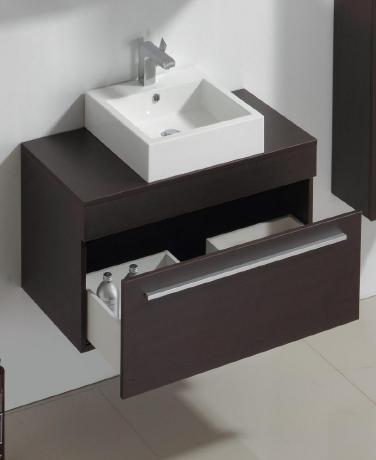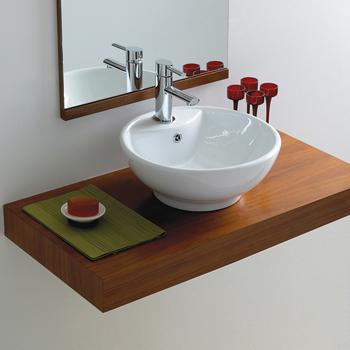The first image is the image on the left, the second image is the image on the right. Evaluate the accuracy of this statement regarding the images: "There is a mirror behind one of the sinks.". Is it true? Answer yes or no. Yes. 